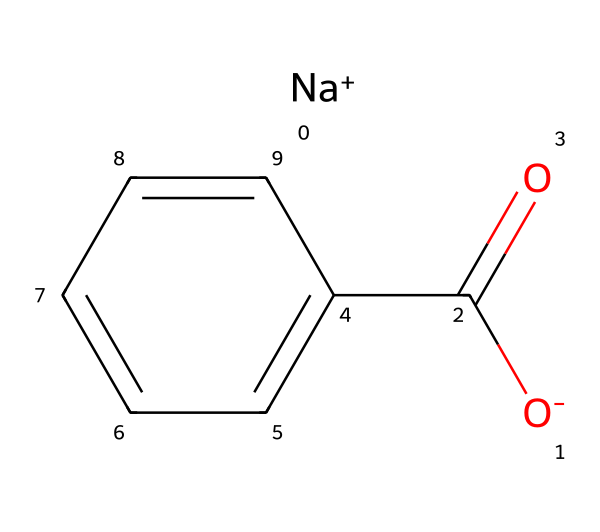How many carbon atoms are present in sodium benzoate? From the SMILES representation, we can visualize that there are six carbon atoms in the benzene ring and one carbon in the carboxylate group (COO-), totaling seven carbon atoms.
Answer: seven What type of ion does sodium benzoate contain? The SMILES shows the presence of [Na+], indicating that sodium benzoate contains a sodium ion, which is a cation.
Answer: sodium ion What is the functional group present in sodium benzoate? Looking at the chemical structure, we can identify the carboxylate functional group (COO-), which is characteristic of sodium benzoate as a preservative.
Answer: carboxylate Which part of the molecule is responsible for its preservative properties? The carboxylate (COO-) part of sodium benzoate interacts with microbial membranes, inhibiting their growth, which is why it acts as a preservative.
Answer: carboxylate How many oxygen atoms are there in sodium benzoate? In the SMILES representation, there are two oxygen atoms in the carboxylate group (COO-), confirming that sodium benzoate contains two oxygen atoms.
Answer: two What does the presence of the benzene ring suggest about sodium benzoate's properties? The benzene ring indicates that sodium benzoate has aromatic properties, which can contribute to its stability and effectiveness as a preservative due to its structure.
Answer: aromatic properties 